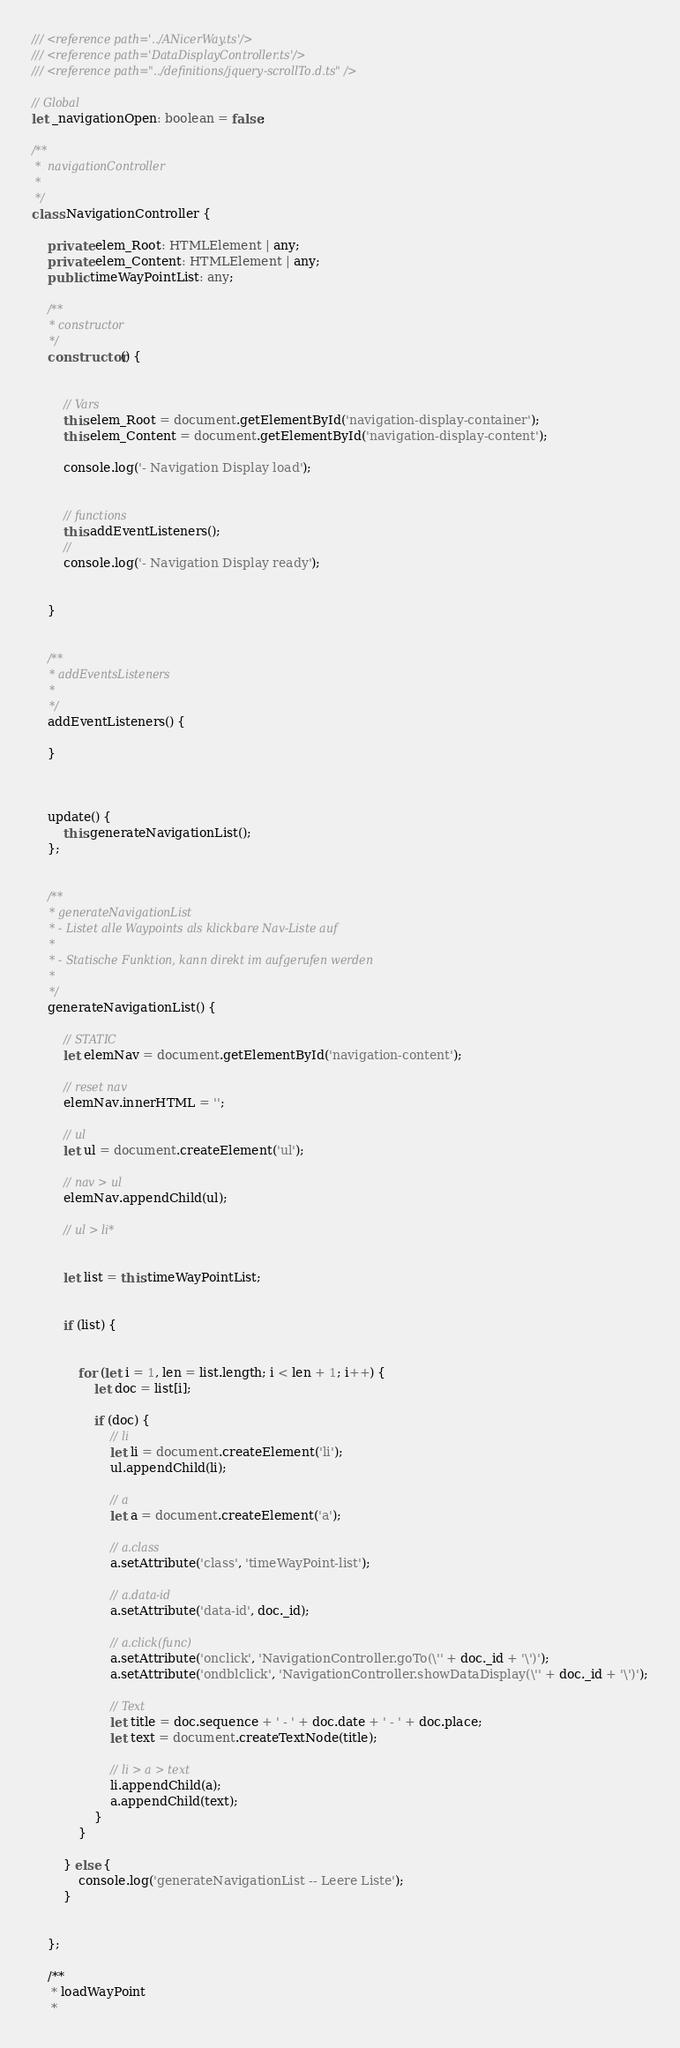<code> <loc_0><loc_0><loc_500><loc_500><_TypeScript_>/// <reference path='../ANicerWay.ts'/>
/// <reference path='DataDisplayController.ts'/>
/// <reference path="../definitions/jquery-scrollTo.d.ts" />

// Global
let _navigationOpen: boolean = false;

/**
 *  navigationController
 *
 */
class NavigationController {

    private elem_Root: HTMLElement | any;
    private elem_Content: HTMLElement | any;
    public timeWayPointList: any;

    /**
     * constructor
     */
    constructor() {


        // Vars
        this.elem_Root = document.getElementById('navigation-display-container');
        this.elem_Content = document.getElementById('navigation-display-content');

        console.log('- Navigation Display load');


        // functions
        this.addEventListeners();
        //
        console.log('- Navigation Display ready');


    }


    /**
     * addEventsListeners
     *
     */
    addEventListeners() {

    }



    update() {
        this.generateNavigationList();
    };


    /**
     * generateNavigationList
     * - Listet alle Waypoints als klickbare Nav-Liste auf
     *
     * - Statische Funktion, kann direkt im aufgerufen werden
     *
     */
    generateNavigationList() {

        // STATIC
        let elemNav = document.getElementById('navigation-content');

        // reset nav
        elemNav.innerHTML = '';

        // ul
        let ul = document.createElement('ul');

        // nav > ul
        elemNav.appendChild(ul);

        // ul > li*


        let list = this.timeWayPointList;


        if (list) {


            for (let i = 1, len = list.length; i < len + 1; i++) {
                let doc = list[i];

                if (doc) {
                    // li
                    let li = document.createElement('li');
                    ul.appendChild(li);

                    // a
                    let a = document.createElement('a');

                    // a.class
                    a.setAttribute('class', 'timeWayPoint-list');

                    // a.data-id
                    a.setAttribute('data-id', doc._id);

                    // a.click(func)
                    a.setAttribute('onclick', 'NavigationController.goTo(\'' + doc._id + '\')');
                    a.setAttribute('ondblclick', 'NavigationController.showDataDisplay(\'' + doc._id + '\')');

                    // Text
                    let title = doc.sequence + ' - ' + doc.date + ' - ' + doc.place;
                    let text = document.createTextNode(title);

                    // li > a > text
                    li.appendChild(a);
                    a.appendChild(text);
                }
            }

        } else {
            console.log('generateNavigationList -- Leere Liste');
        }


    };

    /**
     * loadWayPoint
     *</code> 